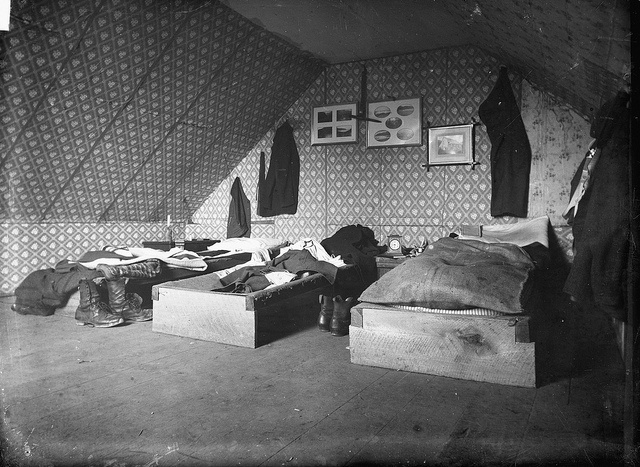Describe the objects in this image and their specific colors. I can see bed in white, darkgray, gray, lightgray, and black tones, bed in white, black, lightgray, gray, and darkgray tones, bed in white, black, gray, and darkgray tones, and clock in white, lightgray, gray, darkgray, and black tones in this image. 